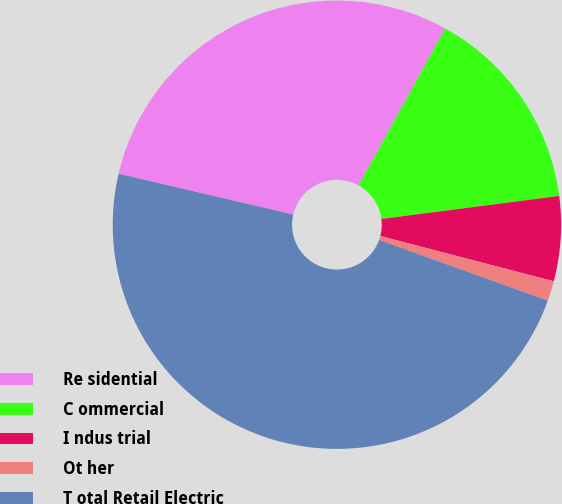Convert chart. <chart><loc_0><loc_0><loc_500><loc_500><pie_chart><fcel>Re sidential<fcel>C ommercial<fcel>I ndus trial<fcel>Ot her<fcel>T otal Retail Electric<nl><fcel>29.37%<fcel>14.93%<fcel>6.11%<fcel>1.44%<fcel>48.15%<nl></chart> 